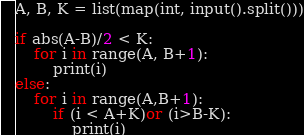<code> <loc_0><loc_0><loc_500><loc_500><_Python_>A, B, K = list(map(int, input().split()))

if abs(A-B)/2 < K:
    for i in range(A, B+1):
        print(i)
else:
    for i in range(A,B+1):        
        if (i < A+K)or (i>B-K):
            print(i)</code> 